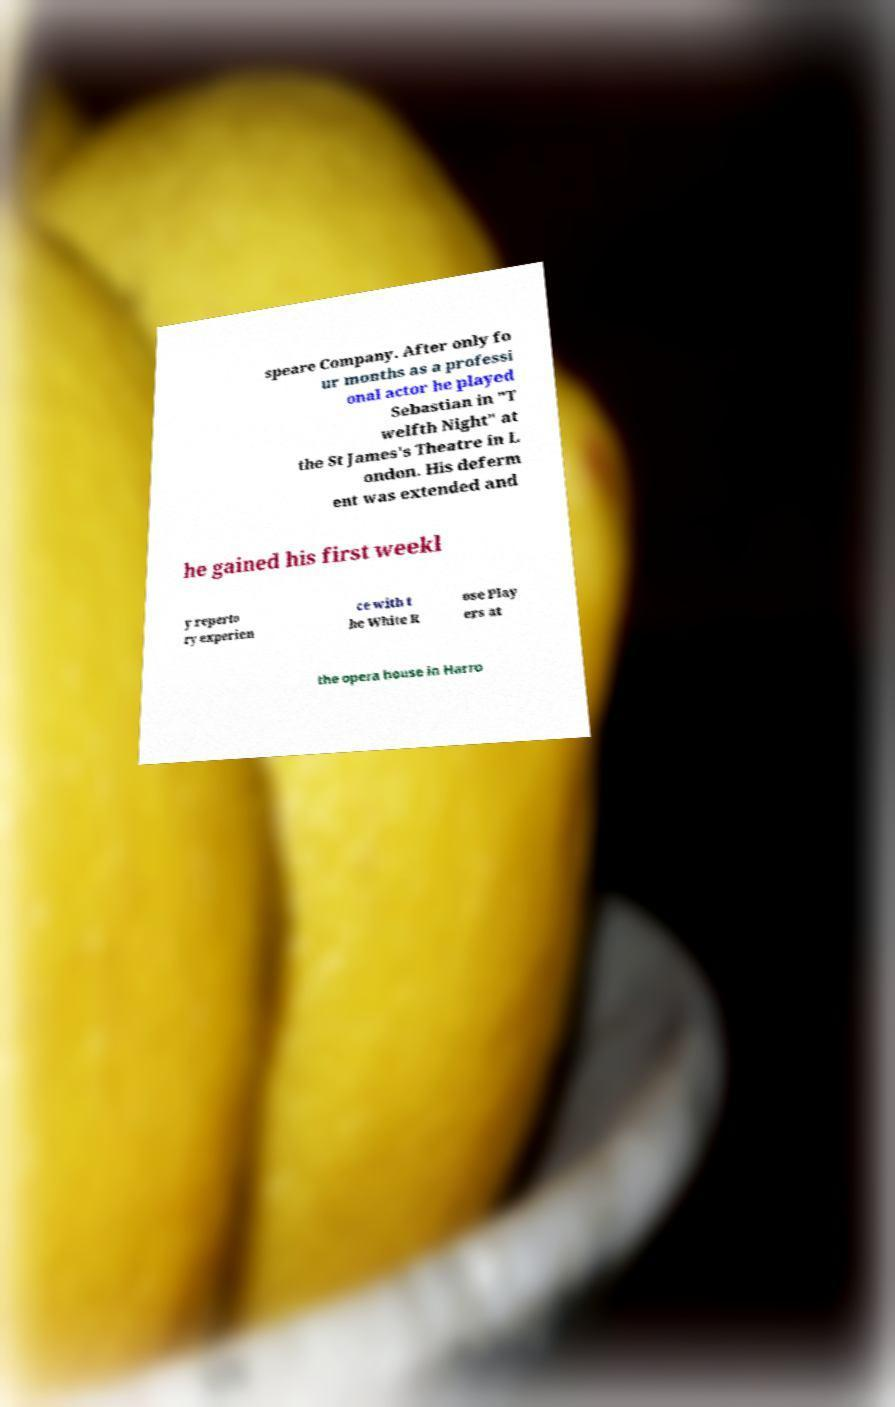Can you accurately transcribe the text from the provided image for me? speare Company. After only fo ur months as a professi onal actor he played Sebastian in "T welfth Night" at the St James's Theatre in L ondon. His deferm ent was extended and he gained his first weekl y reperto ry experien ce with t he White R ose Play ers at the opera house in Harro 